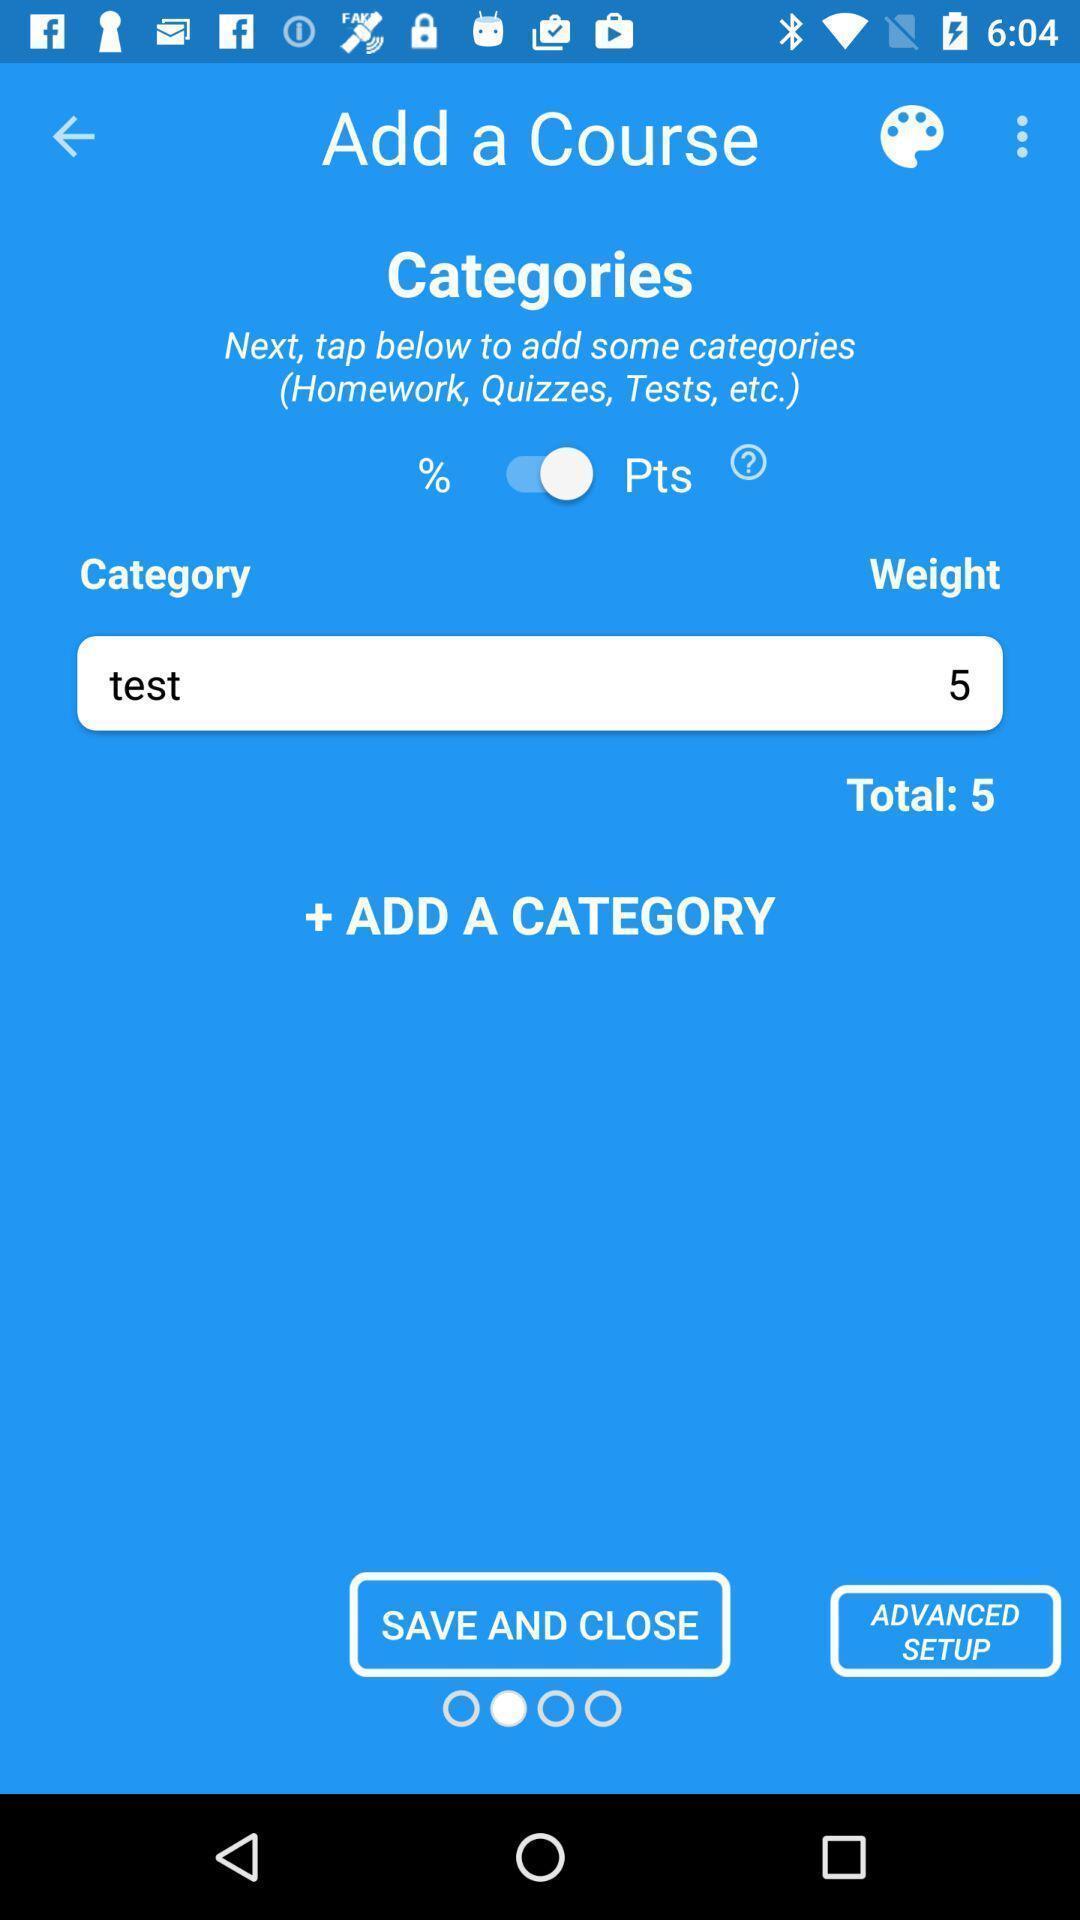Tell me what you see in this picture. Screen shows category details of a learning ap. 